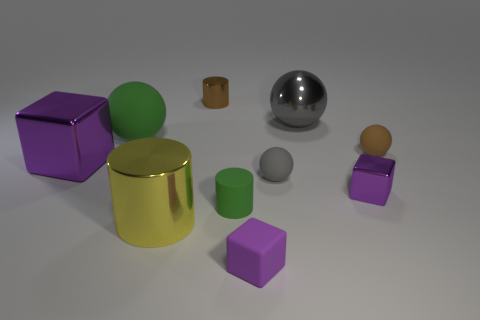Subtract all large cubes. How many cubes are left? 2 Add 5 small gray rubber objects. How many small gray rubber objects exist? 6 Subtract all yellow cylinders. How many cylinders are left? 2 Subtract 3 purple cubes. How many objects are left? 7 Subtract all blocks. How many objects are left? 7 Subtract 2 cylinders. How many cylinders are left? 1 Subtract all green balls. Subtract all cyan cylinders. How many balls are left? 3 Subtract all red blocks. How many cyan spheres are left? 0 Subtract all small rubber cylinders. Subtract all purple matte things. How many objects are left? 8 Add 3 matte things. How many matte things are left? 8 